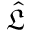Convert formula to latex. <formula><loc_0><loc_0><loc_500><loc_500>\hat { \mathfrak L }</formula> 